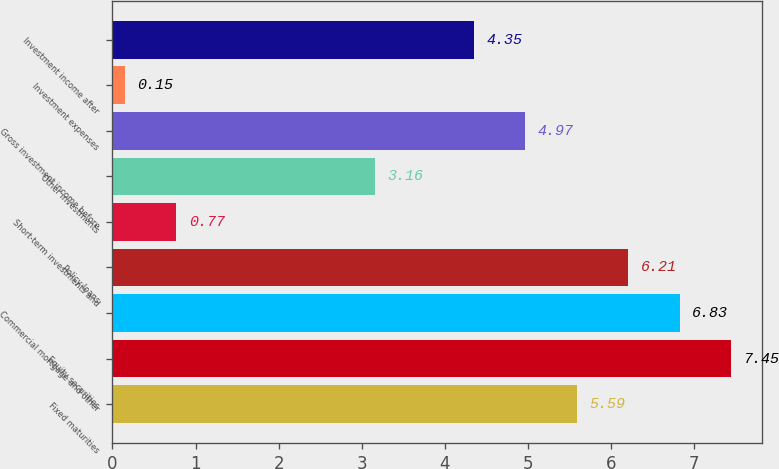Convert chart to OTSL. <chart><loc_0><loc_0><loc_500><loc_500><bar_chart><fcel>Fixed maturities<fcel>Equity securities<fcel>Commercial mortgage and other<fcel>Policy loans<fcel>Short-term investments and<fcel>Other investments<fcel>Gross investment income before<fcel>Investment expenses<fcel>Investment income after<nl><fcel>5.59<fcel>7.45<fcel>6.83<fcel>6.21<fcel>0.77<fcel>3.16<fcel>4.97<fcel>0.15<fcel>4.35<nl></chart> 